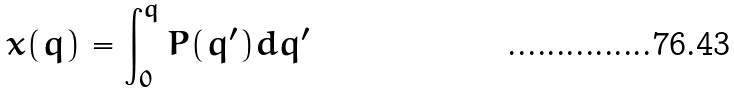<formula> <loc_0><loc_0><loc_500><loc_500>x ( q ) = \int _ { 0 } ^ { q } P ( q ^ { \prime } ) d q ^ { \prime }</formula> 